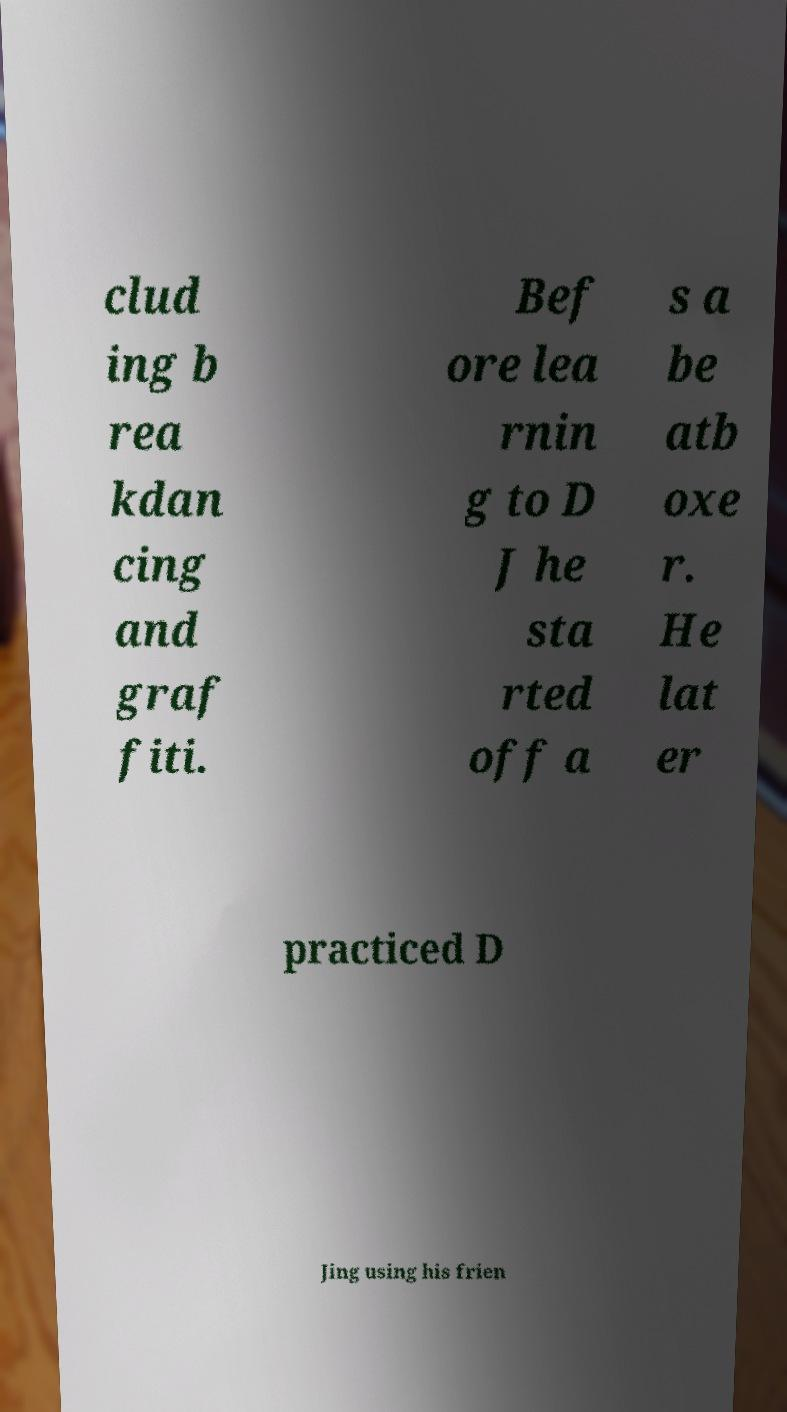For documentation purposes, I need the text within this image transcribed. Could you provide that? clud ing b rea kdan cing and graf fiti. Bef ore lea rnin g to D J he sta rted off a s a be atb oxe r. He lat er practiced D Jing using his frien 